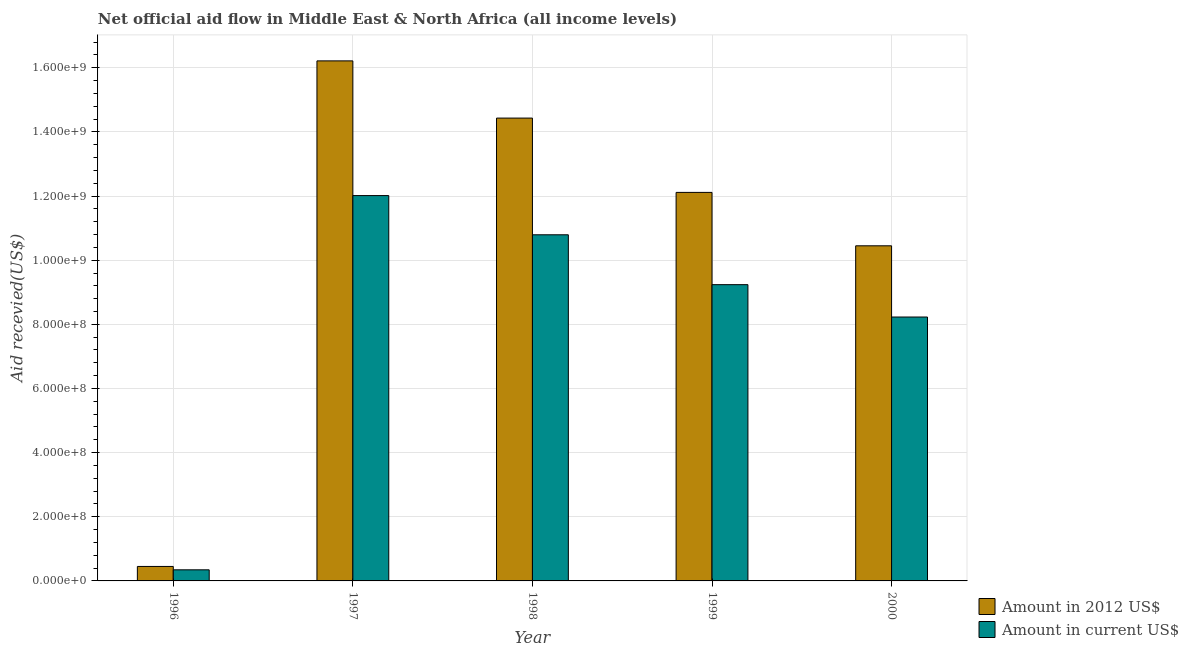How many different coloured bars are there?
Provide a succinct answer. 2. Are the number of bars per tick equal to the number of legend labels?
Your answer should be compact. Yes. How many bars are there on the 1st tick from the left?
Keep it short and to the point. 2. What is the label of the 5th group of bars from the left?
Your answer should be compact. 2000. In how many cases, is the number of bars for a given year not equal to the number of legend labels?
Offer a terse response. 0. What is the amount of aid received(expressed in 2012 us$) in 2000?
Offer a very short reply. 1.04e+09. Across all years, what is the maximum amount of aid received(expressed in us$)?
Provide a short and direct response. 1.20e+09. Across all years, what is the minimum amount of aid received(expressed in us$)?
Ensure brevity in your answer.  3.46e+07. What is the total amount of aid received(expressed in us$) in the graph?
Ensure brevity in your answer.  4.06e+09. What is the difference between the amount of aid received(expressed in 2012 us$) in 1996 and that in 2000?
Provide a succinct answer. -1.00e+09. What is the difference between the amount of aid received(expressed in 2012 us$) in 1996 and the amount of aid received(expressed in us$) in 1998?
Your answer should be very brief. -1.40e+09. What is the average amount of aid received(expressed in 2012 us$) per year?
Your answer should be compact. 1.07e+09. In the year 1999, what is the difference between the amount of aid received(expressed in us$) and amount of aid received(expressed in 2012 us$)?
Provide a short and direct response. 0. In how many years, is the amount of aid received(expressed in 2012 us$) greater than 800000000 US$?
Keep it short and to the point. 4. What is the ratio of the amount of aid received(expressed in 2012 us$) in 1998 to that in 1999?
Give a very brief answer. 1.19. What is the difference between the highest and the second highest amount of aid received(expressed in 2012 us$)?
Offer a terse response. 1.78e+08. What is the difference between the highest and the lowest amount of aid received(expressed in 2012 us$)?
Your answer should be compact. 1.58e+09. In how many years, is the amount of aid received(expressed in us$) greater than the average amount of aid received(expressed in us$) taken over all years?
Give a very brief answer. 4. Is the sum of the amount of aid received(expressed in us$) in 1997 and 1999 greater than the maximum amount of aid received(expressed in 2012 us$) across all years?
Provide a succinct answer. Yes. What does the 2nd bar from the left in 1999 represents?
Ensure brevity in your answer.  Amount in current US$. What does the 1st bar from the right in 1999 represents?
Offer a very short reply. Amount in current US$. How many bars are there?
Make the answer very short. 10. How many years are there in the graph?
Your answer should be compact. 5. What is the difference between two consecutive major ticks on the Y-axis?
Provide a short and direct response. 2.00e+08. Are the values on the major ticks of Y-axis written in scientific E-notation?
Your answer should be compact. Yes. Does the graph contain any zero values?
Offer a very short reply. No. What is the title of the graph?
Provide a succinct answer. Net official aid flow in Middle East & North Africa (all income levels). Does "Old" appear as one of the legend labels in the graph?
Offer a very short reply. No. What is the label or title of the X-axis?
Provide a short and direct response. Year. What is the label or title of the Y-axis?
Ensure brevity in your answer.  Aid recevied(US$). What is the Aid recevied(US$) in Amount in 2012 US$ in 1996?
Your answer should be compact. 4.51e+07. What is the Aid recevied(US$) in Amount in current US$ in 1996?
Provide a succinct answer. 3.46e+07. What is the Aid recevied(US$) of Amount in 2012 US$ in 1997?
Offer a terse response. 1.62e+09. What is the Aid recevied(US$) of Amount in current US$ in 1997?
Give a very brief answer. 1.20e+09. What is the Aid recevied(US$) in Amount in 2012 US$ in 1998?
Provide a succinct answer. 1.44e+09. What is the Aid recevied(US$) in Amount in current US$ in 1998?
Offer a very short reply. 1.08e+09. What is the Aid recevied(US$) of Amount in 2012 US$ in 1999?
Keep it short and to the point. 1.21e+09. What is the Aid recevied(US$) in Amount in current US$ in 1999?
Keep it short and to the point. 9.24e+08. What is the Aid recevied(US$) of Amount in 2012 US$ in 2000?
Offer a terse response. 1.04e+09. What is the Aid recevied(US$) in Amount in current US$ in 2000?
Offer a terse response. 8.23e+08. Across all years, what is the maximum Aid recevied(US$) in Amount in 2012 US$?
Offer a very short reply. 1.62e+09. Across all years, what is the maximum Aid recevied(US$) of Amount in current US$?
Offer a very short reply. 1.20e+09. Across all years, what is the minimum Aid recevied(US$) of Amount in 2012 US$?
Keep it short and to the point. 4.51e+07. Across all years, what is the minimum Aid recevied(US$) of Amount in current US$?
Offer a very short reply. 3.46e+07. What is the total Aid recevied(US$) in Amount in 2012 US$ in the graph?
Ensure brevity in your answer.  5.37e+09. What is the total Aid recevied(US$) of Amount in current US$ in the graph?
Keep it short and to the point. 4.06e+09. What is the difference between the Aid recevied(US$) in Amount in 2012 US$ in 1996 and that in 1997?
Offer a terse response. -1.58e+09. What is the difference between the Aid recevied(US$) in Amount in current US$ in 1996 and that in 1997?
Your answer should be very brief. -1.17e+09. What is the difference between the Aid recevied(US$) in Amount in 2012 US$ in 1996 and that in 1998?
Ensure brevity in your answer.  -1.40e+09. What is the difference between the Aid recevied(US$) of Amount in current US$ in 1996 and that in 1998?
Offer a very short reply. -1.04e+09. What is the difference between the Aid recevied(US$) in Amount in 2012 US$ in 1996 and that in 1999?
Offer a very short reply. -1.17e+09. What is the difference between the Aid recevied(US$) of Amount in current US$ in 1996 and that in 1999?
Offer a very short reply. -8.89e+08. What is the difference between the Aid recevied(US$) in Amount in 2012 US$ in 1996 and that in 2000?
Give a very brief answer. -1.00e+09. What is the difference between the Aid recevied(US$) in Amount in current US$ in 1996 and that in 2000?
Make the answer very short. -7.88e+08. What is the difference between the Aid recevied(US$) of Amount in 2012 US$ in 1997 and that in 1998?
Ensure brevity in your answer.  1.78e+08. What is the difference between the Aid recevied(US$) in Amount in current US$ in 1997 and that in 1998?
Ensure brevity in your answer.  1.22e+08. What is the difference between the Aid recevied(US$) in Amount in 2012 US$ in 1997 and that in 1999?
Provide a short and direct response. 4.10e+08. What is the difference between the Aid recevied(US$) of Amount in current US$ in 1997 and that in 1999?
Make the answer very short. 2.78e+08. What is the difference between the Aid recevied(US$) of Amount in 2012 US$ in 1997 and that in 2000?
Your answer should be very brief. 5.77e+08. What is the difference between the Aid recevied(US$) in Amount in current US$ in 1997 and that in 2000?
Keep it short and to the point. 3.79e+08. What is the difference between the Aid recevied(US$) of Amount in 2012 US$ in 1998 and that in 1999?
Give a very brief answer. 2.32e+08. What is the difference between the Aid recevied(US$) in Amount in current US$ in 1998 and that in 1999?
Give a very brief answer. 1.55e+08. What is the difference between the Aid recevied(US$) of Amount in 2012 US$ in 1998 and that in 2000?
Offer a terse response. 3.98e+08. What is the difference between the Aid recevied(US$) in Amount in current US$ in 1998 and that in 2000?
Offer a terse response. 2.56e+08. What is the difference between the Aid recevied(US$) of Amount in 2012 US$ in 1999 and that in 2000?
Ensure brevity in your answer.  1.67e+08. What is the difference between the Aid recevied(US$) in Amount in current US$ in 1999 and that in 2000?
Your response must be concise. 1.01e+08. What is the difference between the Aid recevied(US$) in Amount in 2012 US$ in 1996 and the Aid recevied(US$) in Amount in current US$ in 1997?
Your answer should be compact. -1.16e+09. What is the difference between the Aid recevied(US$) in Amount in 2012 US$ in 1996 and the Aid recevied(US$) in Amount in current US$ in 1998?
Your answer should be compact. -1.03e+09. What is the difference between the Aid recevied(US$) of Amount in 2012 US$ in 1996 and the Aid recevied(US$) of Amount in current US$ in 1999?
Offer a very short reply. -8.79e+08. What is the difference between the Aid recevied(US$) of Amount in 2012 US$ in 1996 and the Aid recevied(US$) of Amount in current US$ in 2000?
Your response must be concise. -7.78e+08. What is the difference between the Aid recevied(US$) in Amount in 2012 US$ in 1997 and the Aid recevied(US$) in Amount in current US$ in 1998?
Provide a succinct answer. 5.42e+08. What is the difference between the Aid recevied(US$) in Amount in 2012 US$ in 1997 and the Aid recevied(US$) in Amount in current US$ in 1999?
Give a very brief answer. 6.98e+08. What is the difference between the Aid recevied(US$) in Amount in 2012 US$ in 1997 and the Aid recevied(US$) in Amount in current US$ in 2000?
Make the answer very short. 7.99e+08. What is the difference between the Aid recevied(US$) of Amount in 2012 US$ in 1998 and the Aid recevied(US$) of Amount in current US$ in 1999?
Your answer should be compact. 5.19e+08. What is the difference between the Aid recevied(US$) in Amount in 2012 US$ in 1998 and the Aid recevied(US$) in Amount in current US$ in 2000?
Offer a very short reply. 6.20e+08. What is the difference between the Aid recevied(US$) of Amount in 2012 US$ in 1999 and the Aid recevied(US$) of Amount in current US$ in 2000?
Give a very brief answer. 3.89e+08. What is the average Aid recevied(US$) in Amount in 2012 US$ per year?
Provide a succinct answer. 1.07e+09. What is the average Aid recevied(US$) of Amount in current US$ per year?
Offer a very short reply. 8.12e+08. In the year 1996, what is the difference between the Aid recevied(US$) in Amount in 2012 US$ and Aid recevied(US$) in Amount in current US$?
Your answer should be very brief. 1.05e+07. In the year 1997, what is the difference between the Aid recevied(US$) of Amount in 2012 US$ and Aid recevied(US$) of Amount in current US$?
Offer a terse response. 4.20e+08. In the year 1998, what is the difference between the Aid recevied(US$) in Amount in 2012 US$ and Aid recevied(US$) in Amount in current US$?
Give a very brief answer. 3.64e+08. In the year 1999, what is the difference between the Aid recevied(US$) in Amount in 2012 US$ and Aid recevied(US$) in Amount in current US$?
Provide a short and direct response. 2.88e+08. In the year 2000, what is the difference between the Aid recevied(US$) of Amount in 2012 US$ and Aid recevied(US$) of Amount in current US$?
Your answer should be very brief. 2.22e+08. What is the ratio of the Aid recevied(US$) of Amount in 2012 US$ in 1996 to that in 1997?
Ensure brevity in your answer.  0.03. What is the ratio of the Aid recevied(US$) of Amount in current US$ in 1996 to that in 1997?
Ensure brevity in your answer.  0.03. What is the ratio of the Aid recevied(US$) of Amount in 2012 US$ in 1996 to that in 1998?
Provide a short and direct response. 0.03. What is the ratio of the Aid recevied(US$) in Amount in current US$ in 1996 to that in 1998?
Offer a terse response. 0.03. What is the ratio of the Aid recevied(US$) of Amount in 2012 US$ in 1996 to that in 1999?
Keep it short and to the point. 0.04. What is the ratio of the Aid recevied(US$) in Amount in current US$ in 1996 to that in 1999?
Your answer should be compact. 0.04. What is the ratio of the Aid recevied(US$) in Amount in 2012 US$ in 1996 to that in 2000?
Keep it short and to the point. 0.04. What is the ratio of the Aid recevied(US$) in Amount in current US$ in 1996 to that in 2000?
Provide a succinct answer. 0.04. What is the ratio of the Aid recevied(US$) in Amount in 2012 US$ in 1997 to that in 1998?
Make the answer very short. 1.12. What is the ratio of the Aid recevied(US$) in Amount in current US$ in 1997 to that in 1998?
Provide a succinct answer. 1.11. What is the ratio of the Aid recevied(US$) in Amount in 2012 US$ in 1997 to that in 1999?
Your answer should be compact. 1.34. What is the ratio of the Aid recevied(US$) in Amount in current US$ in 1997 to that in 1999?
Provide a short and direct response. 1.3. What is the ratio of the Aid recevied(US$) of Amount in 2012 US$ in 1997 to that in 2000?
Keep it short and to the point. 1.55. What is the ratio of the Aid recevied(US$) in Amount in current US$ in 1997 to that in 2000?
Provide a short and direct response. 1.46. What is the ratio of the Aid recevied(US$) in Amount in 2012 US$ in 1998 to that in 1999?
Offer a very short reply. 1.19. What is the ratio of the Aid recevied(US$) in Amount in current US$ in 1998 to that in 1999?
Ensure brevity in your answer.  1.17. What is the ratio of the Aid recevied(US$) in Amount in 2012 US$ in 1998 to that in 2000?
Provide a short and direct response. 1.38. What is the ratio of the Aid recevied(US$) in Amount in current US$ in 1998 to that in 2000?
Your answer should be compact. 1.31. What is the ratio of the Aid recevied(US$) in Amount in 2012 US$ in 1999 to that in 2000?
Offer a very short reply. 1.16. What is the ratio of the Aid recevied(US$) of Amount in current US$ in 1999 to that in 2000?
Make the answer very short. 1.12. What is the difference between the highest and the second highest Aid recevied(US$) in Amount in 2012 US$?
Offer a very short reply. 1.78e+08. What is the difference between the highest and the second highest Aid recevied(US$) in Amount in current US$?
Give a very brief answer. 1.22e+08. What is the difference between the highest and the lowest Aid recevied(US$) in Amount in 2012 US$?
Give a very brief answer. 1.58e+09. What is the difference between the highest and the lowest Aid recevied(US$) in Amount in current US$?
Ensure brevity in your answer.  1.17e+09. 